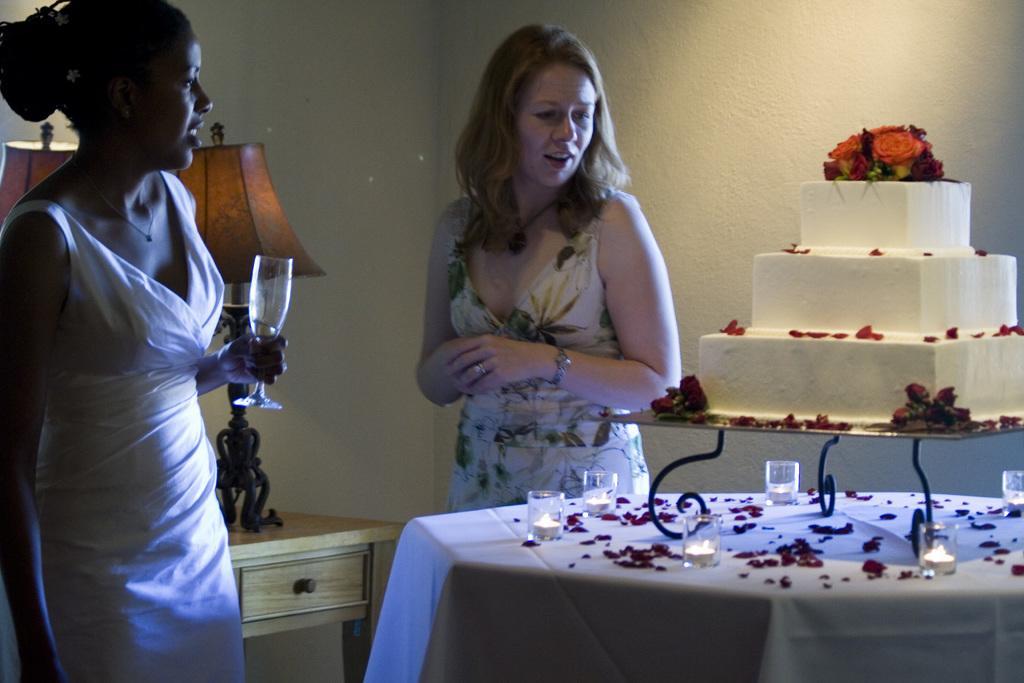How would you summarize this image in a sentence or two? On the left side, there is a woman in a white color dress holding a glass and smiling. On the right side, there are glasses, flower petals and a stand on which there is a cake arranged. In the background, there are two lights arranged on a table and there is a wall. 